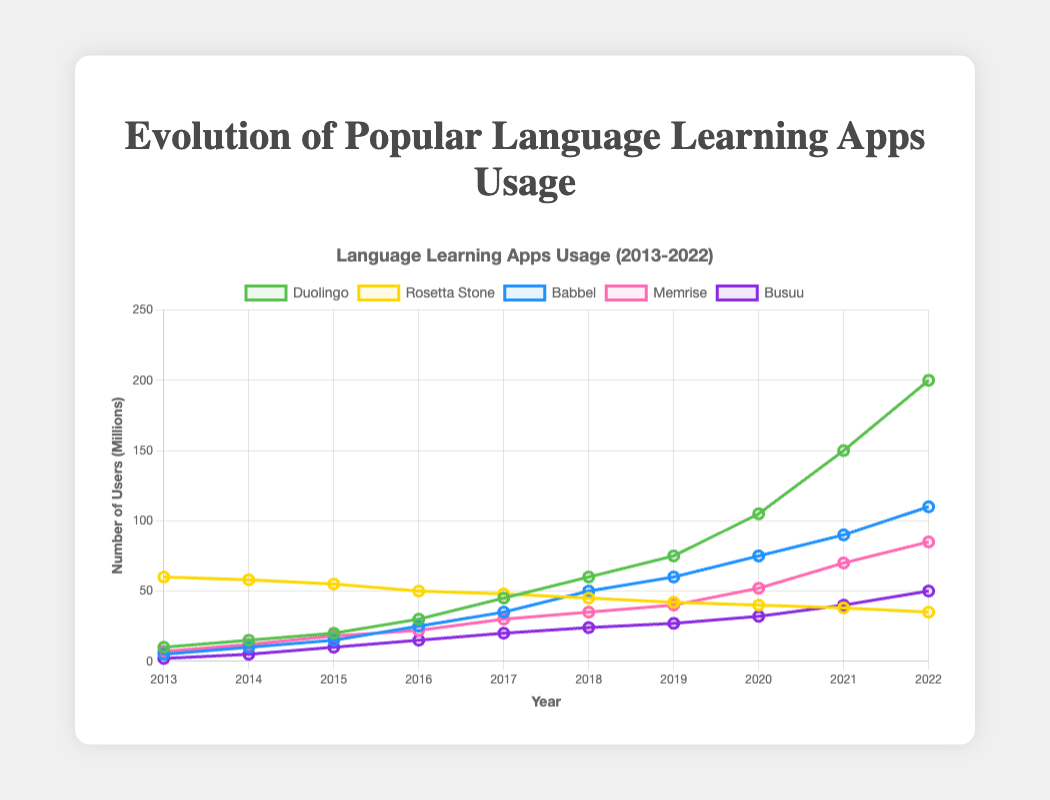What was the total number of users across all apps in 2013? To find the total number of users in 2013, simply sum the users of all apps in that year: Duolingo (10), Rosetta Stone (60), Babbel (5), Memrise (7), and Busuu (2). Thus, 10 + 60 + 5 + 7 + 2 = 84 million users.
Answer: 84 million Which app experienced the highest growth in users from 2013 to 2022? To determine the app with the highest growth, subtract the number of users in 2013 from those in 2022 for each app: Duolingo (200-10=190), Rosetta Stone (35-60=-25), Babbel (110-5=105), Memrise (85-7=78), and Busuu (50-2=48). Duolingo had the highest increase with 190 million users.
Answer: Duolingo How did Babbel's number of users in 2020 compare to that of Memrise in the same year? Babbel had 75 million users in 2020, while Memrise had 52 million. Comparing these values, Babbel had more users.
Answer: Babbel had more Which apps saw a consistent increase in users each year over the decade? By visually scanning the lines for each app, we observe that Duolingo, Babbel, Memrise, and Busuu had steadily increasing trends without any year-on-year decline.
Answer: Duolingo, Babbel, Memrise, Busuu In which year did Rosetta Stone have the smallest number of users? Visually inspecting Rosetta Stone's line, we see it had the smallest number of users in 2022 with 35 million.
Answer: 2022 Compare the number of users for Duolingo and Babbel in 2017. Who had more users, and by how much? In 2017, Duolingo had 45 million users and Babbel had 35 million users. Duolingo had 10 million more users than Babbel.
Answer: Duolingo by 10 million What is the average number of users for Busuu over the decade? To find the average, sum up Busuu's yearly users and divide by the number of years: (2 + 5 + 10 + 15 + 20 + 24 + 27 + 32 + 40 + 50) / 10 = 22.5.
Answer: 22.5 million Identify the year with the largest increase in users for Duolingo. Comparing the yearly differences for Duolingo, the largest increase was from 2019 to 2020 (105-75=30 million users).
Answer: 2020 